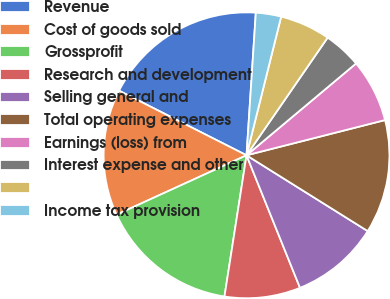Convert chart to OTSL. <chart><loc_0><loc_0><loc_500><loc_500><pie_chart><fcel>Revenue<fcel>Cost of goods sold<fcel>Grossprofit<fcel>Research and development<fcel>Selling general and<fcel>Total operating expenses<fcel>Earnings (loss) from<fcel>Interest expense and other<fcel>Unnamed: 8<fcel>Income tax provision<nl><fcel>18.57%<fcel>14.29%<fcel>15.71%<fcel>8.57%<fcel>10.0%<fcel>12.86%<fcel>7.14%<fcel>4.29%<fcel>5.71%<fcel>2.86%<nl></chart> 